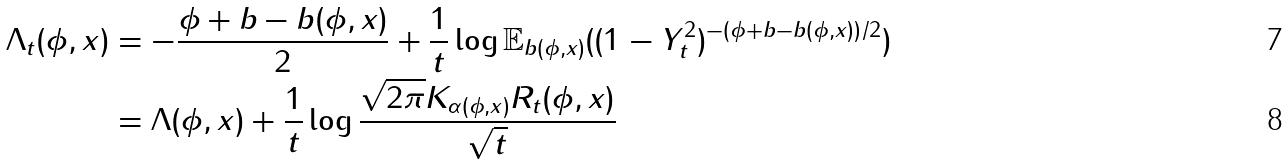<formula> <loc_0><loc_0><loc_500><loc_500>\Lambda _ { t } ( \phi , x ) & = - \frac { \phi + b - b ( \phi , x ) } { 2 } + \frac { 1 } { t } \log \mathbb { E } _ { b ( \phi , x ) } ( ( 1 - Y _ { t } ^ { 2 } ) ^ { - ( \phi + b - b ( \phi , x ) ) / 2 } ) \\ & = \Lambda ( \phi , x ) + \frac { 1 } { t } \log \frac { \sqrt { 2 \pi } K _ { \alpha ( \phi , x ) } R _ { t } ( \phi , x ) } { \sqrt { t } }</formula> 